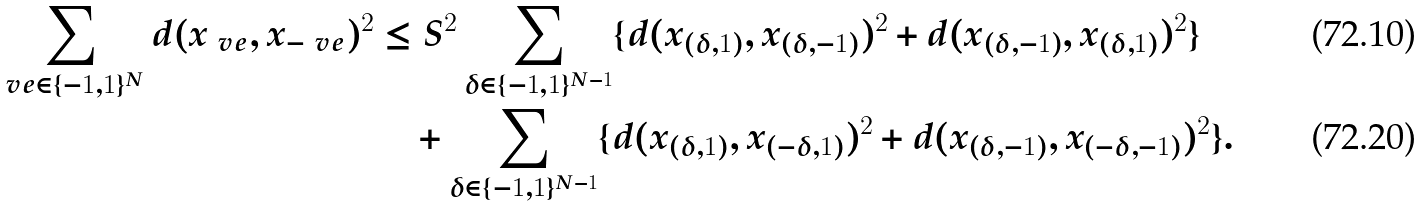Convert formula to latex. <formula><loc_0><loc_0><loc_500><loc_500>\sum _ { \ v e \in \{ - 1 , 1 \} ^ { N } } d ( x _ { \ v e } , x _ { - \ v e } ) ^ { 2 } & \leq S ^ { 2 } \sum _ { \delta \in \{ - 1 , 1 \} ^ { N - 1 } } \{ d ( x _ { ( \delta , 1 ) } , x _ { ( \delta , - 1 ) } ) ^ { 2 } + d ( x _ { ( \delta , - 1 ) } , x _ { ( \delta , 1 ) } ) ^ { 2 } \} \\ & \quad + \sum _ { \delta \in \{ - 1 , 1 \} ^ { N - 1 } } \{ d ( x _ { ( \delta , 1 ) } , x _ { ( - \delta , 1 ) } ) ^ { 2 } + d ( x _ { ( \delta , - 1 ) } , x _ { ( - \delta , - 1 ) } ) ^ { 2 } \} .</formula> 